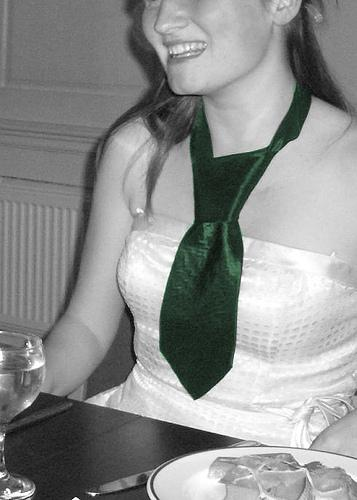Mention the primary figure in the image and their appearance. A young woman with long hair wearing a white dress and a green tie, sitting at a table and smiling. Explain the key subject of the image and how they appear. The highlight of the image is a joyful young lady in a white dress and green tie, seated at a table with various items around her. Describe the prominent person in the image and their demeanor. The picture showcases a happy, long-haired woman wearing a white dress and green tie, sitting at a table. Write a concise statement about the main character and their appearance in the image. Young, smiling lady wearing white dress and green tie, with long hair, seated at a table. Provide a brief account of the foremost figure in the image and their expression. The image features an elegant young woman in a white dress and green tie, emanating joy as she sits at a table. What is the main focus of the image and what action is being performed? The main focus is a smiling young woman in a white dress, seated at a table containing various items. Provide a description of the main figure and the setting in the image. A smiling woman with long hair, clad in a white dress and a green tie, is seen sitting at a table with multiple objects. Painterly describe the primary individual in the image and their current state. The portrait captures a beaming young woman, her elegant white dress complemented by a green tie, gracefully sitting at a table with an array of objects. State the main subject of the image and briefly describe their appearance. The central figure is a woman who has long hair, is wearing a white dress and green tie, and is smiling while seated at a table. 